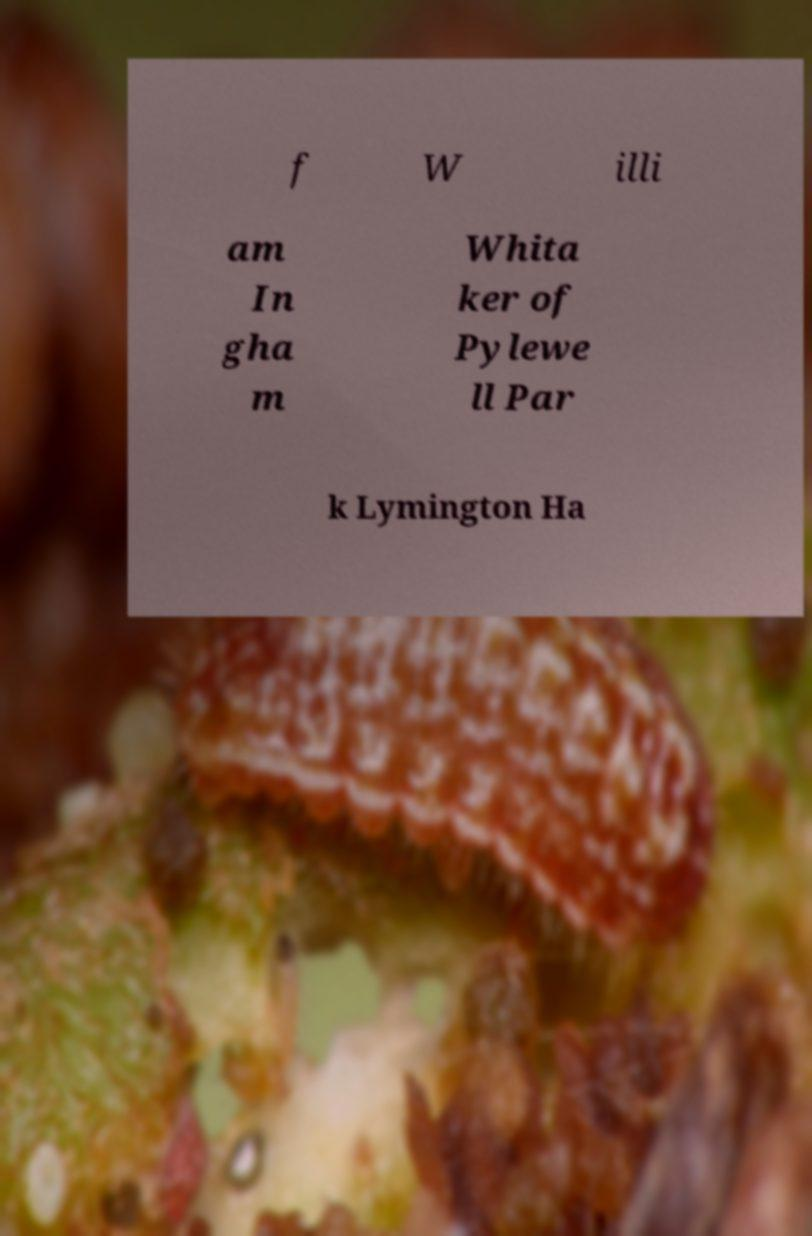What messages or text are displayed in this image? I need them in a readable, typed format. f W illi am In gha m Whita ker of Pylewe ll Par k Lymington Ha 